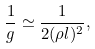<formula> <loc_0><loc_0><loc_500><loc_500>\frac { 1 } { g } \simeq \frac { 1 } { 2 ( \rho l ) ^ { 2 } } ,</formula> 